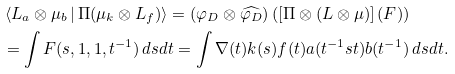Convert formula to latex. <formula><loc_0><loc_0><loc_500><loc_500>& \left \langle L _ { a } \otimes \mu _ { b } \, | \, \Pi ( \mu _ { k } \otimes L _ { f } ) \right \rangle = ( \varphi _ { D } \otimes \widehat { \varphi _ { D } } ) \left ( \left [ \Pi \otimes ( L \otimes \mu ) \right ] ( F ) \right ) \\ & = \int F ( s , 1 , 1 , t ^ { - 1 } ) \, d s d t = \int \nabla ( t ) k ( s ) f ( t ) a ( t ^ { - 1 } s t ) b ( t ^ { - 1 } ) \, d s d t .</formula> 